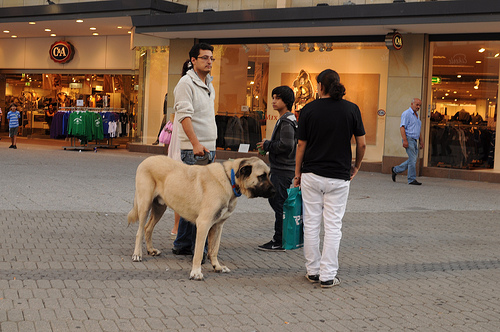What animal is the man to the left of the bag holding onto? The animal that the man to the left of the bag is holding onto is a dog, visible as a significant part of the scene. 